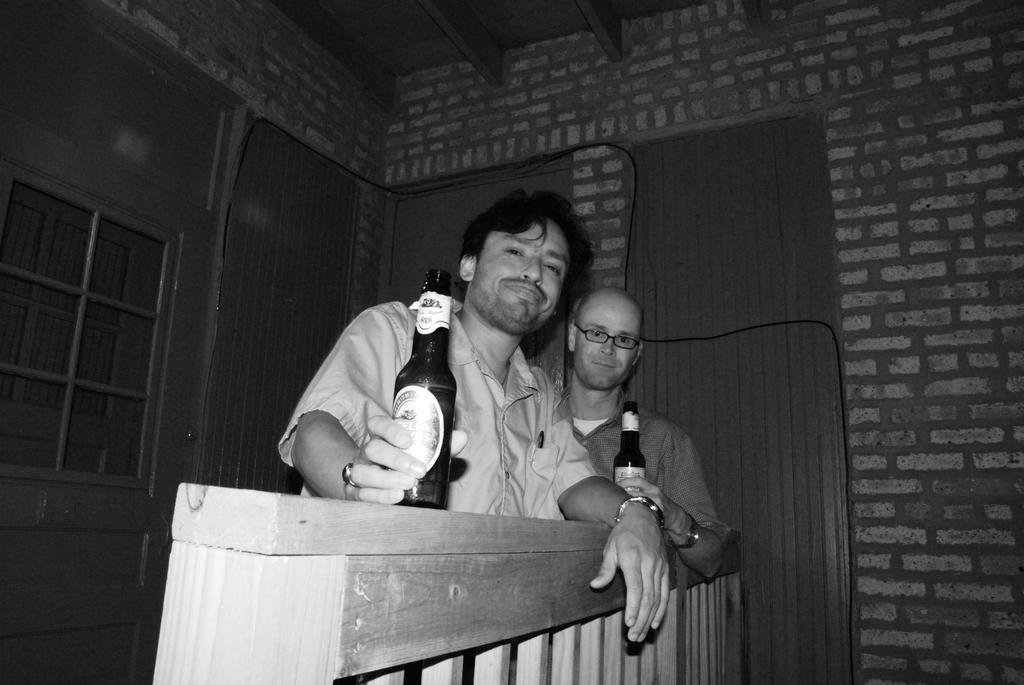How many people are in the image? There are two persons in the image. What are the persons doing in the image? The persons are standing in the image. What are the persons holding in the image? The persons are holding a wine bottle in the image. What is in front of the persons in the image? There is a wooden fence in front of the persons in the image. What can be seen in the background of the image? There is a brick wall in the background of the image. What type of stick can be seen in the image? There is no stick present in the image. 